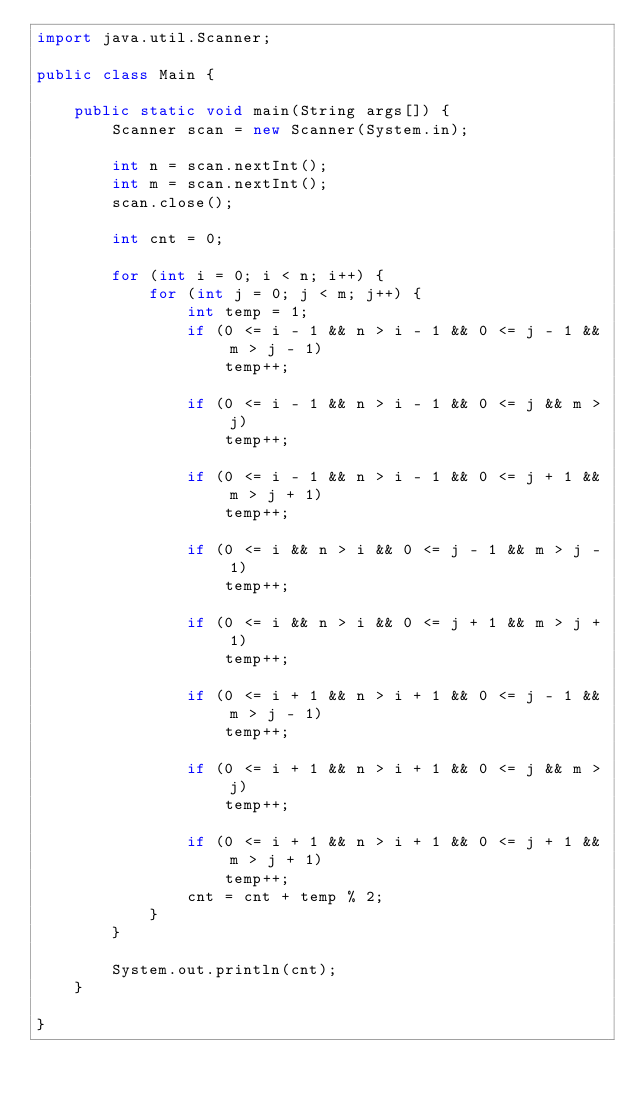<code> <loc_0><loc_0><loc_500><loc_500><_Java_>import java.util.Scanner;

public class Main {

	public static void main(String args[]) {
		Scanner scan = new Scanner(System.in);

		int n = scan.nextInt();
		int m = scan.nextInt();
		scan.close();

		int cnt = 0;

		for (int i = 0; i < n; i++) {
			for (int j = 0; j < m; j++) {
				int temp = 1;
				if (0 <= i - 1 && n > i - 1 && 0 <= j - 1 && m > j - 1)
					temp++;

				if (0 <= i - 1 && n > i - 1 && 0 <= j && m > j)
					temp++;

				if (0 <= i - 1 && n > i - 1 && 0 <= j + 1 && m > j + 1)
					temp++;

				if (0 <= i && n > i && 0 <= j - 1 && m > j - 1)
					temp++;

				if (0 <= i && n > i && 0 <= j + 1 && m > j + 1)
					temp++;

				if (0 <= i + 1 && n > i + 1 && 0 <= j - 1 && m > j - 1)
					temp++;

				if (0 <= i + 1 && n > i + 1 && 0 <= j && m > j)
					temp++;

				if (0 <= i + 1 && n > i + 1 && 0 <= j + 1 && m > j + 1)
					temp++;
				cnt = cnt + temp % 2;
			}
		}

		System.out.println(cnt);
	}

}</code> 